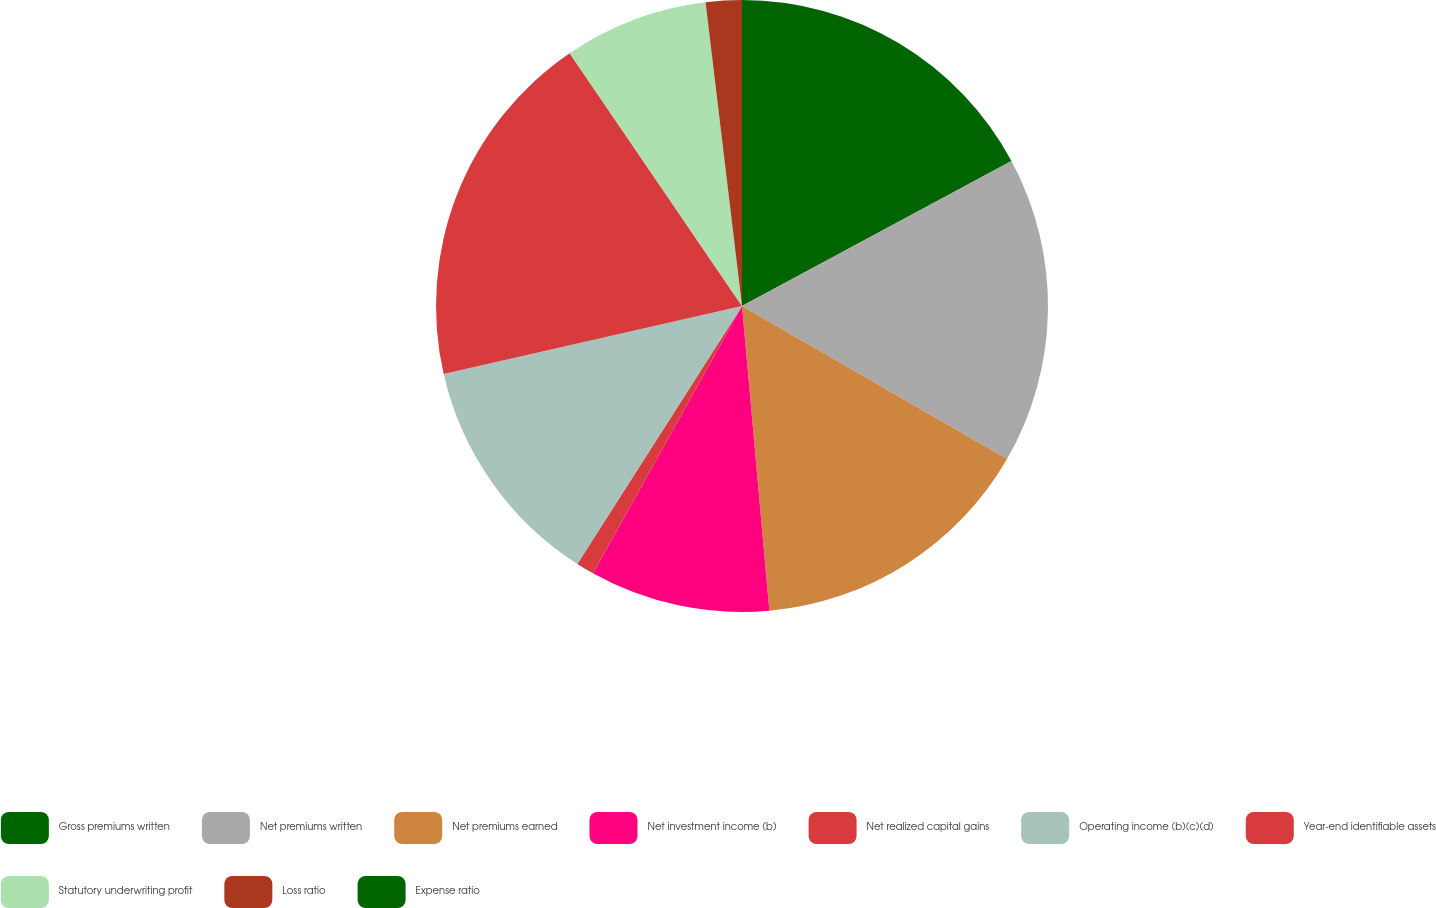Convert chart. <chart><loc_0><loc_0><loc_500><loc_500><pie_chart><fcel>Gross premiums written<fcel>Net premiums written<fcel>Net premiums earned<fcel>Net investment income (b)<fcel>Net realized capital gains<fcel>Operating income (b)(c)(d)<fcel>Year-end identifiable assets<fcel>Statutory underwriting profit<fcel>Loss ratio<fcel>Expense ratio<nl><fcel>17.14%<fcel>16.19%<fcel>15.24%<fcel>9.52%<fcel>0.95%<fcel>12.38%<fcel>19.05%<fcel>7.62%<fcel>1.9%<fcel>0.0%<nl></chart> 